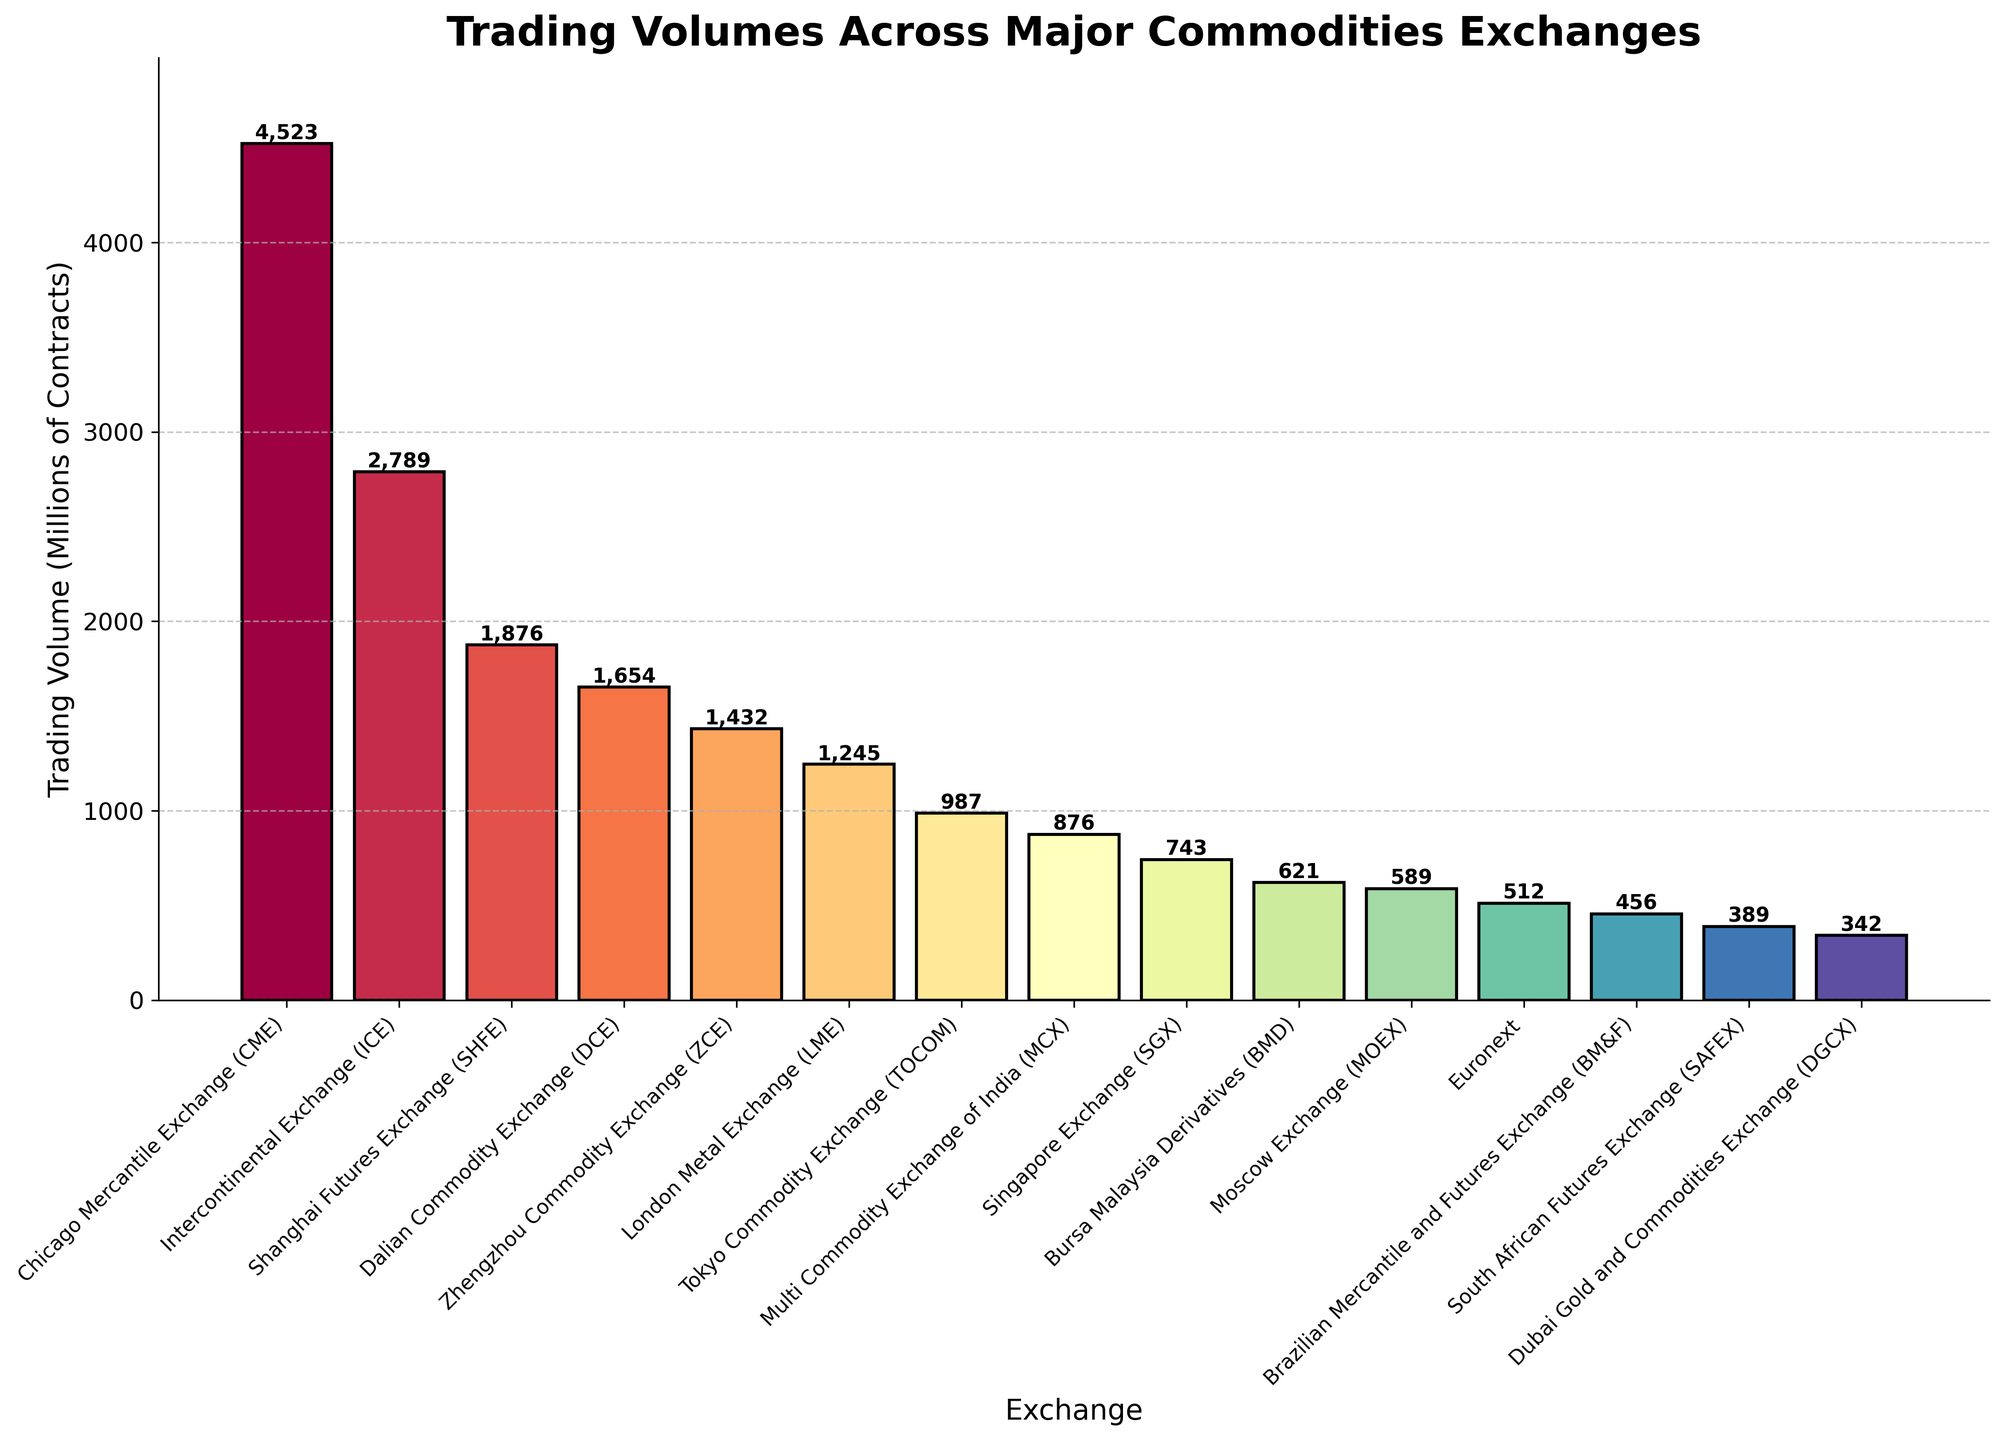Which exchange has the highest trading volume? By examining the height of the bars, the highest bar corresponds to the Chicago Mercantile Exchange (CME) with a trading volume of 4523 million contracts.
Answer: Chicago Mercantile Exchange (CME) How does the trading volume of the London Metal Exchange compare to the Tokyo Commodity Exchange? Looking at the chart, the bar for London Metal Exchange (LME) is slightly higher than the bar for Tokyo Commodity Exchange (TOCOM). LME has a trading volume of 1245 million contracts while TOCOM has 987 million contracts.
Answer: LME has a higher trading volume than TOCOM Which exchanges have trading volumes less than 1000 million contracts? Bars indicating trading volumes less than the 1000-million mark include Tokyo Commodity Exchange (987 million), Multi Commodity Exchange of India (876 million), Singapore Exchange (743 million), Bursa Malaysia Derivatives (621 million), Moscow Exchange (589 million), Euronext (512 million), Brazilian Mercantile and Futures Exchange (456 million), South African Futures Exchange (389 million), and Dubai Gold and Commodities Exchange (342 million).
Answer: TOCOM, MCX, SGX, BMD, MOEX, Euronext, BM&F, SAFEX, DGCX What is the total trading volume of the three Chinese exchanges (SHFE, DCE, ZCE)? To find the total trading volume, sum the trading volumes of Shanghai Futures Exchange (1876 million), Dalian Commodity Exchange (1654 million), and Zhengzhou Commodity Exchange (1432 million). The total is 1876 + 1654 + 1432 = 4962 million contracts.
Answer: 4962 million contracts Which exchange ranks third in trading volume? By looking at the height of the bars, the third tallest bar is for Shanghai Futures Exchange (SHFE) with a trading volume of 1876 million contracts.
Answer: Shanghai Futures Exchange (SHFE) How much higher is the trading volume of CME compared to SHFE? The trading volume of CME is 4523 million contracts and SHFE is 1876 million contracts. The difference is 4523 - 1876 = 2647 million contracts.
Answer: 2647 million contracts What's the average trading volume of the exchanges shown? First, sum all the trading volumes: 4523 + 2789 + 1876 + 1654 + 1432 + 1245 + 987 + 876 + 743 + 621 + 589 + 512 + 456 + 389 + 342 = 20034 million contracts. There are 15 exchanges, so the average is 20034 / 15 ≈ 1336 million contracts.
Answer: 1336 million contracts Identify the exchange with the lowest trading volume and its volume. The shortest bar on the chart corresponds to the Dubai Gold and Commodities Exchange (DGCX) with a trading volume of 342 million contracts.
Answer: Dubai Gold and Commodities Exchange (DGCX), 342 million contracts 